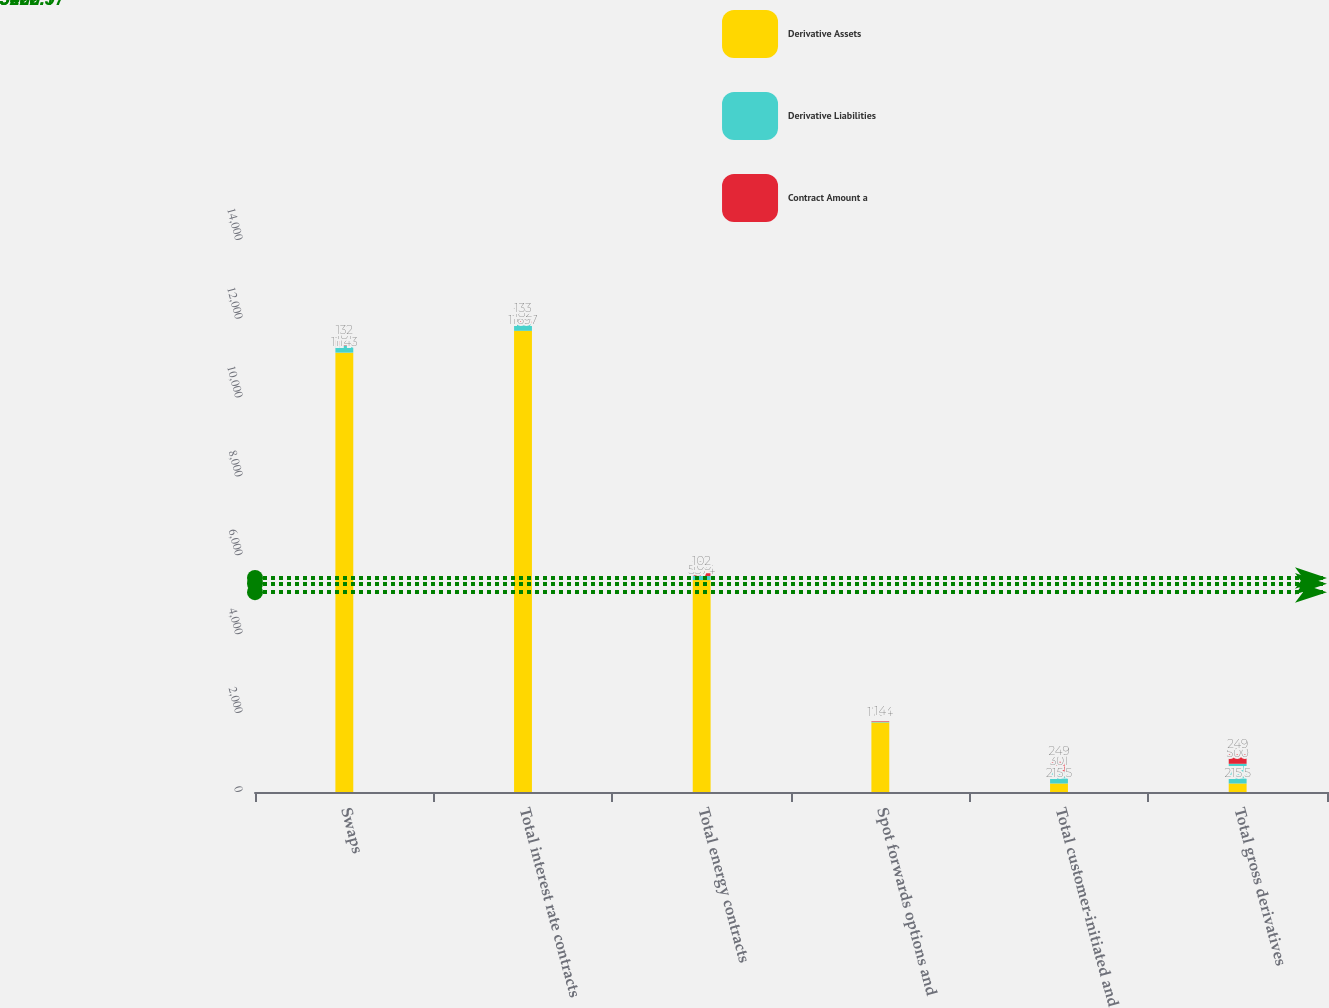Convert chart. <chart><loc_0><loc_0><loc_500><loc_500><stacked_bar_chart><ecel><fcel>Swaps<fcel>Total interest rate contracts<fcel>Total energy contracts<fcel>Spot forwards options and<fcel>Total customer-initiated and<fcel>Total gross derivatives<nl><fcel>Derivative Assets<fcel>11143<fcel>11697<fcel>5374<fcel>1764<fcel>215.5<fcel>215.5<nl><fcel>Derivative Liabilities<fcel>181<fcel>182<fcel>105<fcel>14<fcel>301<fcel>500<nl><fcel>Contract Amount a<fcel>132<fcel>133<fcel>102<fcel>14<fcel>249<fcel>249<nl></chart> 